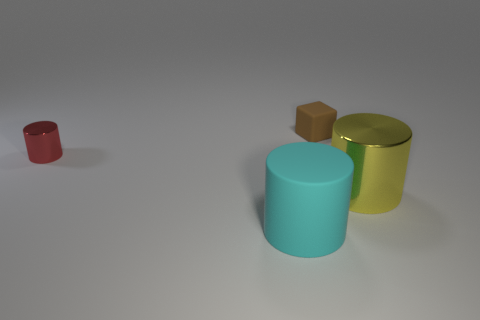What number of rubber things are cyan objects or red cylinders?
Your answer should be compact. 1. Is the shape of the metal object behind the yellow cylinder the same as the rubber thing that is in front of the brown cube?
Provide a short and direct response. Yes. There is a thing that is behind the large yellow thing and to the right of the small red object; what is its color?
Give a very brief answer. Brown. Is the size of the object in front of the yellow cylinder the same as the matte object behind the large yellow shiny cylinder?
Offer a very short reply. No. What number of tiny objects are cylinders or red metal things?
Offer a very short reply. 1. Is the material of the tiny red object left of the brown block the same as the cyan cylinder?
Offer a very short reply. No. What is the color of the cube that is behind the large rubber cylinder?
Make the answer very short. Brown. Is there a red object of the same size as the brown thing?
Offer a terse response. Yes. There is a brown object that is the same size as the red cylinder; what is it made of?
Ensure brevity in your answer.  Rubber. There is a red object; is it the same size as the metal cylinder to the right of the tiny brown rubber cube?
Ensure brevity in your answer.  No. 